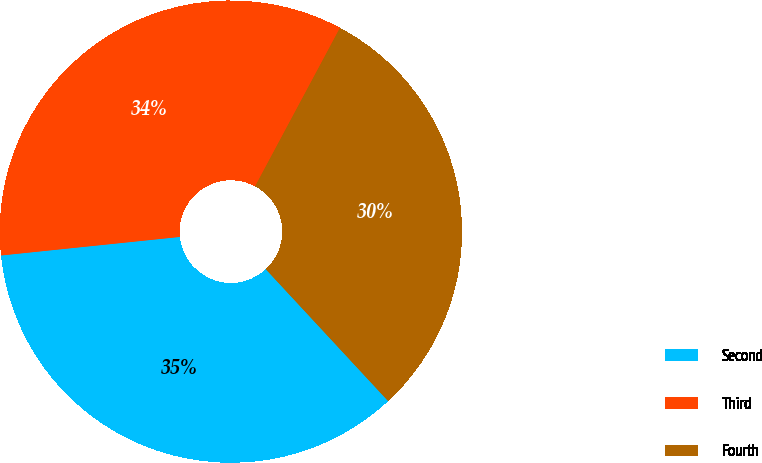Convert chart. <chart><loc_0><loc_0><loc_500><loc_500><pie_chart><fcel>Second<fcel>Third<fcel>Fourth<nl><fcel>35.26%<fcel>34.47%<fcel>30.27%<nl></chart> 